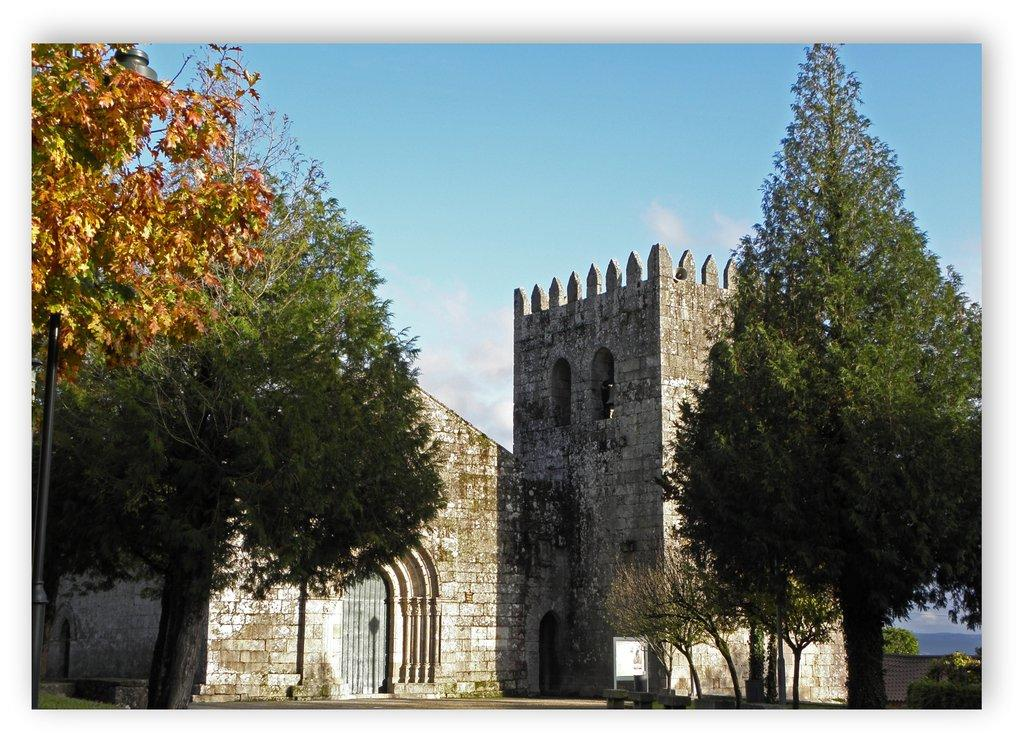What type of vegetation can be seen in the image? There are trees in the image. What type of structure is present in the image? There is a fort in the image. What is the condition of the sky in the image? The sky is clear in the image. How many buttons can be seen on the sail in the image? There is no sail or button present in the image. What type of number is written on the fort in the image? There are no numbers visible on the fort in the image. 